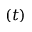Convert formula to latex. <formula><loc_0><loc_0><loc_500><loc_500>\left ( t \right )</formula> 